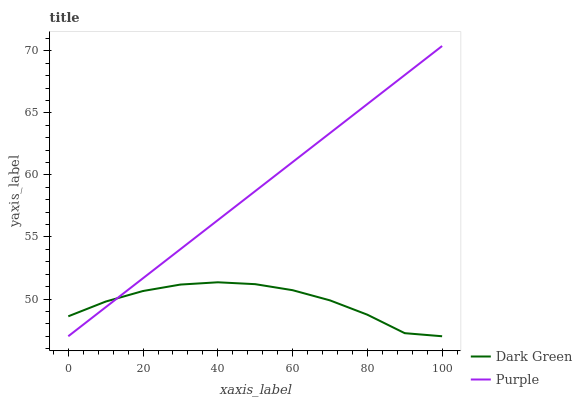Does Dark Green have the minimum area under the curve?
Answer yes or no. Yes. Does Purple have the maximum area under the curve?
Answer yes or no. Yes. Does Dark Green have the maximum area under the curve?
Answer yes or no. No. Is Purple the smoothest?
Answer yes or no. Yes. Is Dark Green the roughest?
Answer yes or no. Yes. Is Dark Green the smoothest?
Answer yes or no. No. Does Purple have the lowest value?
Answer yes or no. Yes. Does Purple have the highest value?
Answer yes or no. Yes. Does Dark Green have the highest value?
Answer yes or no. No. Does Purple intersect Dark Green?
Answer yes or no. Yes. Is Purple less than Dark Green?
Answer yes or no. No. Is Purple greater than Dark Green?
Answer yes or no. No. 